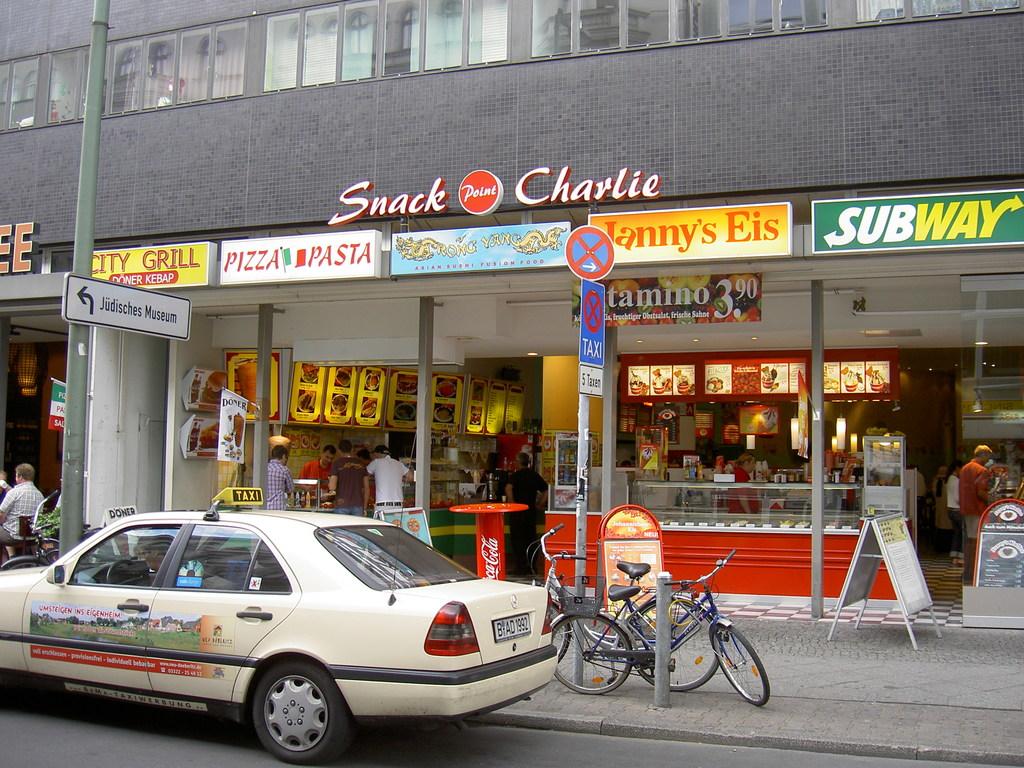What sandwich shop has a green background on their sign?
Provide a short and direct response. Subway. What´s the big name on top of the building?
Offer a very short reply. Snack charlie. 